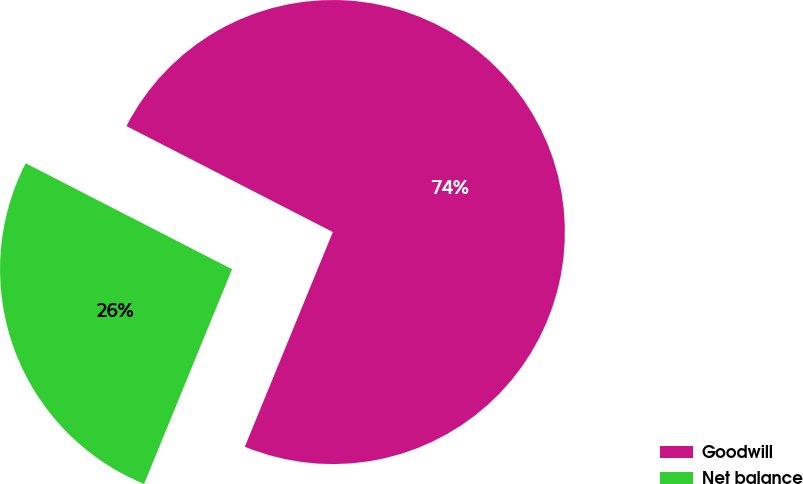Convert chart. <chart><loc_0><loc_0><loc_500><loc_500><pie_chart><fcel>Goodwill<fcel>Net balance<nl><fcel>73.64%<fcel>26.36%<nl></chart> 